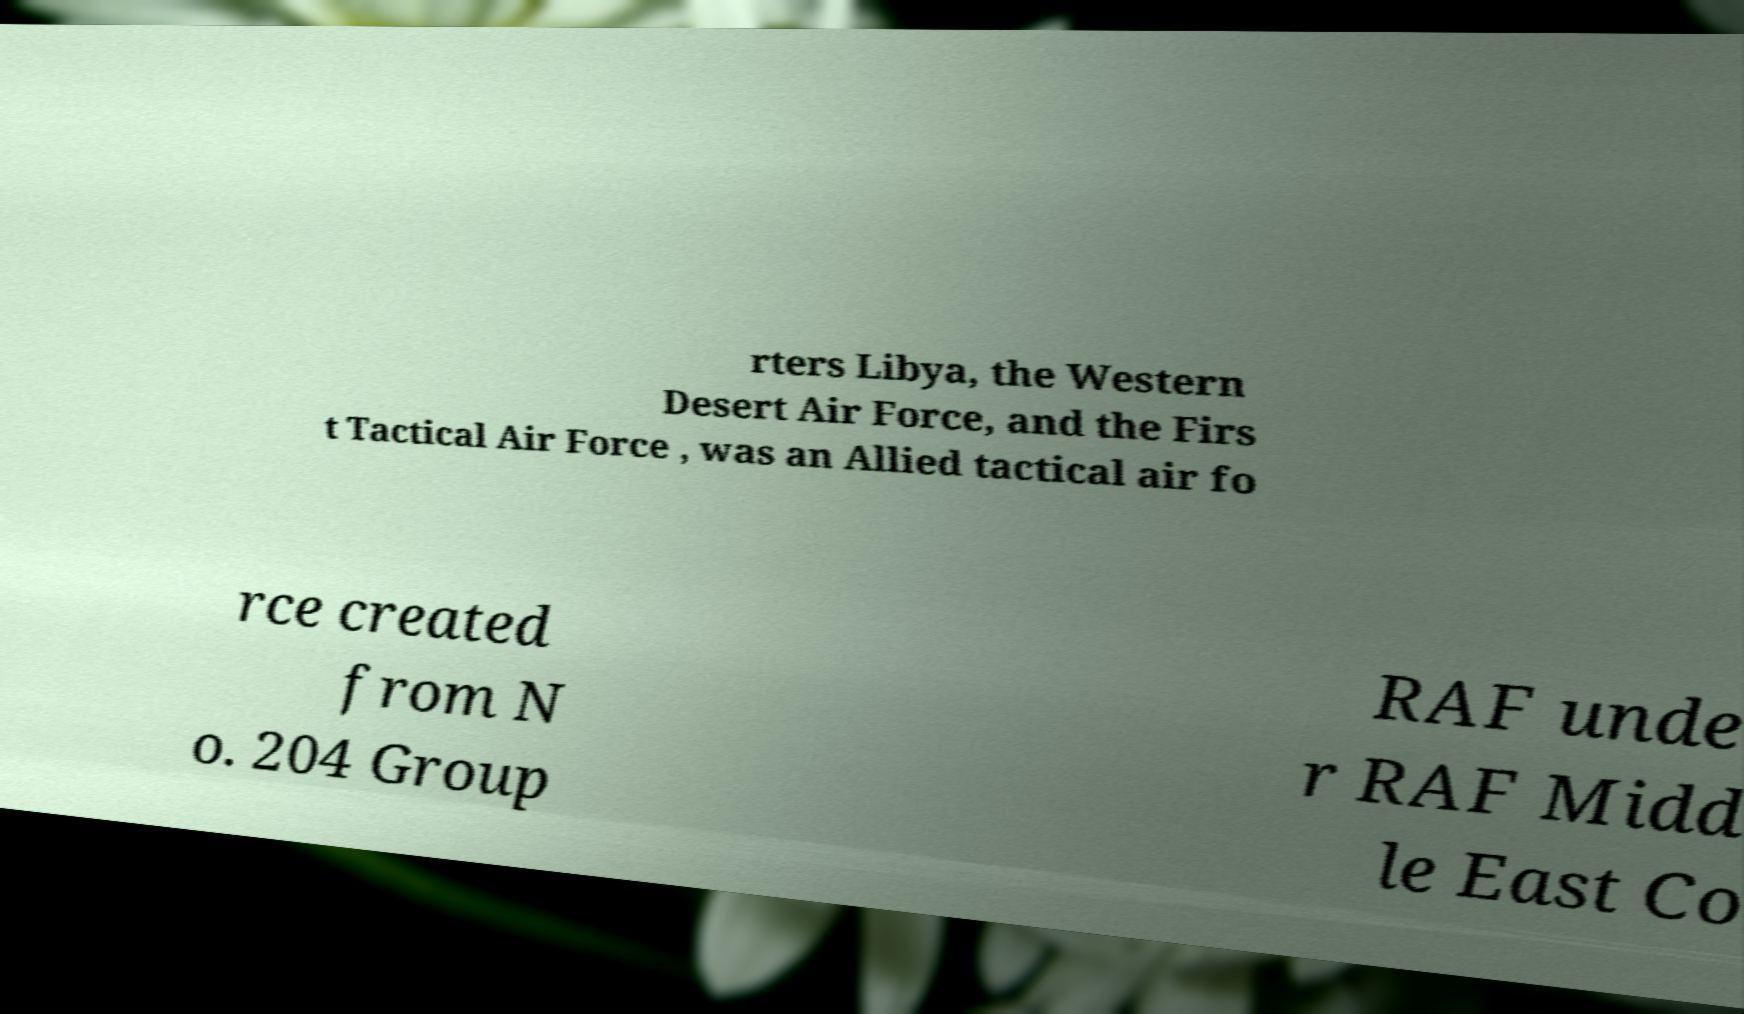Please read and relay the text visible in this image. What does it say? rters Libya, the Western Desert Air Force, and the Firs t Tactical Air Force , was an Allied tactical air fo rce created from N o. 204 Group RAF unde r RAF Midd le East Co 